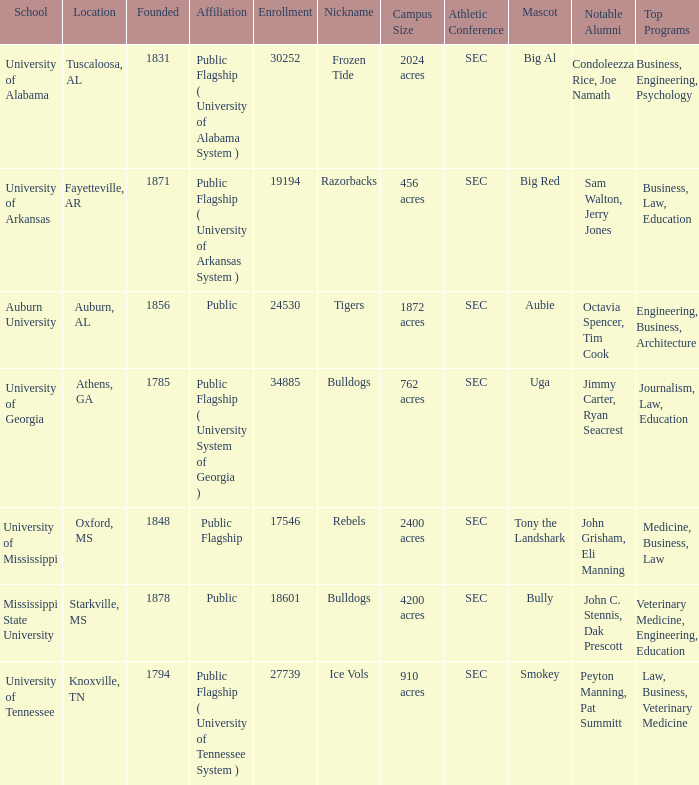What is the nickname of the University of Alabama? Frozen Tide. 